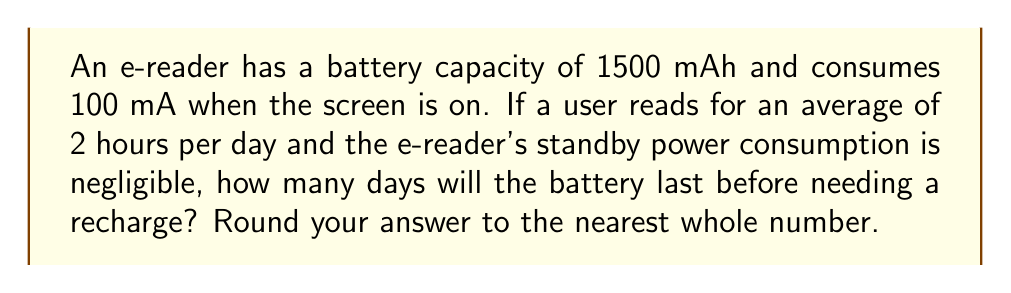Show me your answer to this math problem. Let's approach this step-by-step:

1) First, we need to calculate the daily power consumption:
   Daily usage = 2 hours
   Current draw = 100 mA
   Daily consumption = $100 \text{ mA} \times 2 \text{ hours} = 200 \text{ mAh}$

2) Now, we can set up an equation to find the number of days (x) the battery will last:
   $$1500 \text{ mAh} = 200 \text{ mAh/day} \times x \text{ days}$$

3) Solve for x:
   $$x = \frac{1500 \text{ mAh}}{200 \text{ mAh/day}} = 7.5 \text{ days}$$

4) Rounding to the nearest whole number:
   7.5 rounds up to 8 days

This calculation demonstrates the superior battery life of e-readers compared to traditional tablets or smartphones, making them an excellent choice for avid readers who want to minimize the frequency of recharging their devices.
Answer: 8 days 